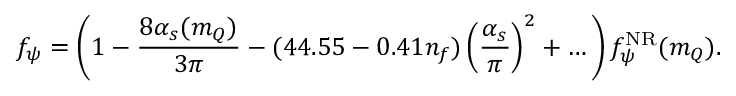<formula> <loc_0><loc_0><loc_500><loc_500>f _ { \psi } = \left ( 1 - \frac { 8 \alpha _ { s } ( m _ { Q } ) } { 3 \pi } - ( 4 4 . 5 5 - 0 . 4 1 n _ { f } ) \left ( \frac { \alpha _ { s } } { \pi } \right ) ^ { 2 } + \dots \, \right ) f _ { \psi } ^ { N R } ( m _ { Q } ) .</formula> 